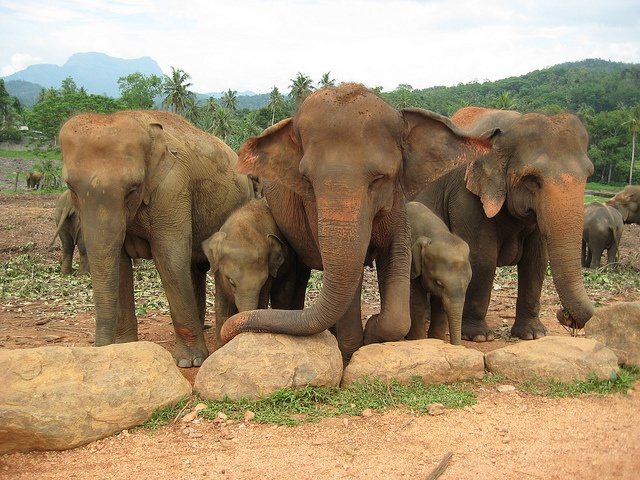Describe the objects in this image and their specific colors. I can see elephant in white, brown, gray, and maroon tones, elephant in white, gray, olive, tan, and maroon tones, elephant in white, black, maroon, and gray tones, elephant in white, black, gray, olive, and maroon tones, and elephant in white, black, gray, and maroon tones in this image. 